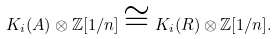<formula> <loc_0><loc_0><loc_500><loc_500>K _ { i } ( A ) \otimes \mathbb { Z } [ 1 / n ] \cong K _ { i } ( R ) \otimes \mathbb { Z } [ 1 / n ] .</formula> 